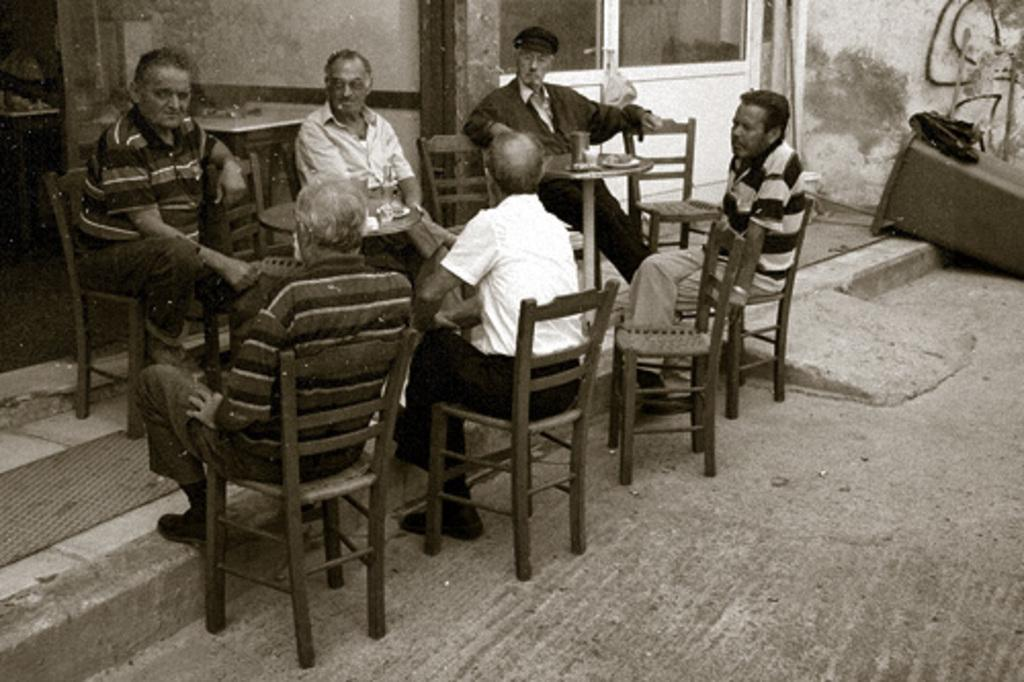How many people are in the image? There is a group of persons in the image. What are the persons doing in the image? The persons are sitting around a table. Where is the table located in the image? The table is on the floor. What type of flowers can be seen on the table in the image? There are no flowers present on the table in the image. How many passengers are visible in the image? The image does not depict any passengers, as it features a group of persons sitting around a table. 